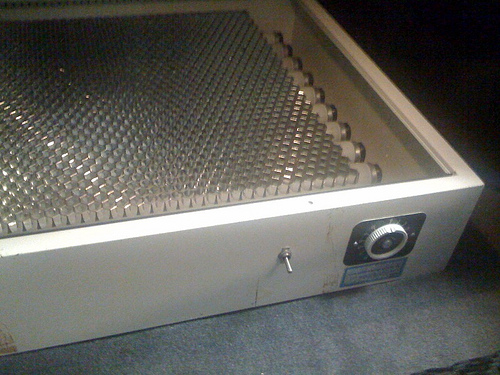<image>
Is the button in the burner? No. The button is not contained within the burner. These objects have a different spatial relationship. 